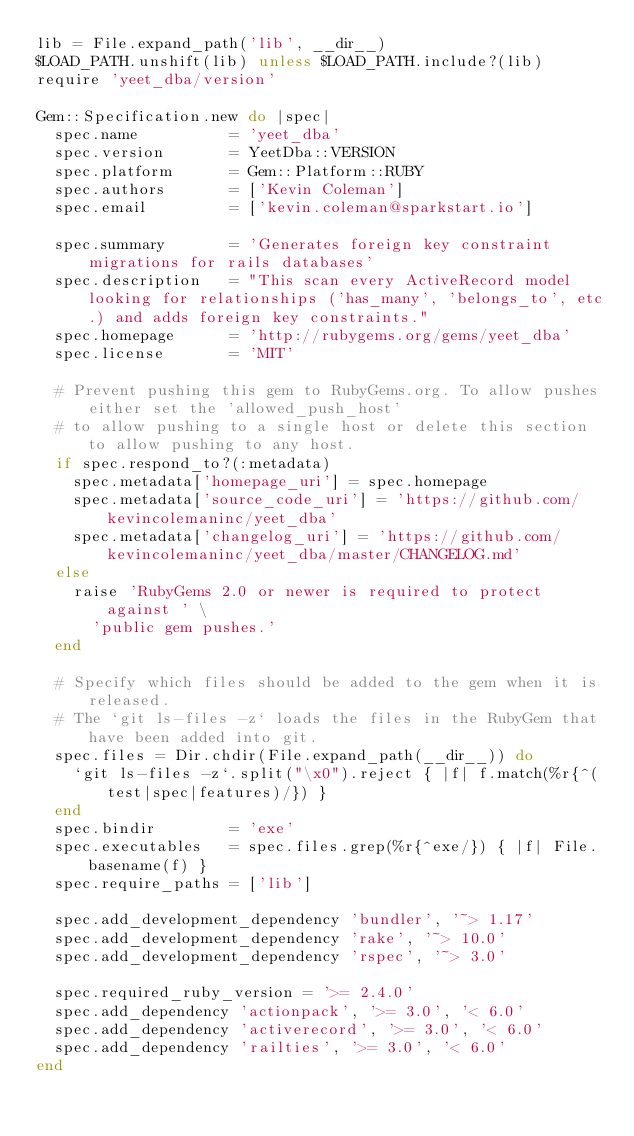<code> <loc_0><loc_0><loc_500><loc_500><_Ruby_>lib = File.expand_path('lib', __dir__)
$LOAD_PATH.unshift(lib) unless $LOAD_PATH.include?(lib)
require 'yeet_dba/version'

Gem::Specification.new do |spec|
  spec.name          = 'yeet_dba'
  spec.version       = YeetDba::VERSION
  spec.platform      = Gem::Platform::RUBY
  spec.authors       = ['Kevin Coleman']
  spec.email         = ['kevin.coleman@sparkstart.io']

  spec.summary       = 'Generates foreign key constraint migrations for rails databases'
  spec.description   = "This scan every ActiveRecord model looking for relationships ('has_many', 'belongs_to', etc.) and adds foreign key constraints."
  spec.homepage      = 'http://rubygems.org/gems/yeet_dba'
  spec.license       = 'MIT'

  # Prevent pushing this gem to RubyGems.org. To allow pushes either set the 'allowed_push_host'
  # to allow pushing to a single host or delete this section to allow pushing to any host.
  if spec.respond_to?(:metadata)
    spec.metadata['homepage_uri'] = spec.homepage
    spec.metadata['source_code_uri'] = 'https://github.com/kevincolemaninc/yeet_dba'
    spec.metadata['changelog_uri'] = 'https://github.com/kevincolemaninc/yeet_dba/master/CHANGELOG.md'
  else
    raise 'RubyGems 2.0 or newer is required to protect against ' \
      'public gem pushes.'
  end

  # Specify which files should be added to the gem when it is released.
  # The `git ls-files -z` loads the files in the RubyGem that have been added into git.
  spec.files = Dir.chdir(File.expand_path(__dir__)) do
    `git ls-files -z`.split("\x0").reject { |f| f.match(%r{^(test|spec|features)/}) }
  end
  spec.bindir        = 'exe'
  spec.executables   = spec.files.grep(%r{^exe/}) { |f| File.basename(f) }
  spec.require_paths = ['lib']

  spec.add_development_dependency 'bundler', '~> 1.17'
  spec.add_development_dependency 'rake', '~> 10.0'
  spec.add_development_dependency 'rspec', '~> 3.0'

  spec.required_ruby_version = '>= 2.4.0'
  spec.add_dependency 'actionpack', '>= 3.0', '< 6.0'
  spec.add_dependency 'activerecord', '>= 3.0', '< 6.0'
  spec.add_dependency 'railties', '>= 3.0', '< 6.0'
end
</code> 